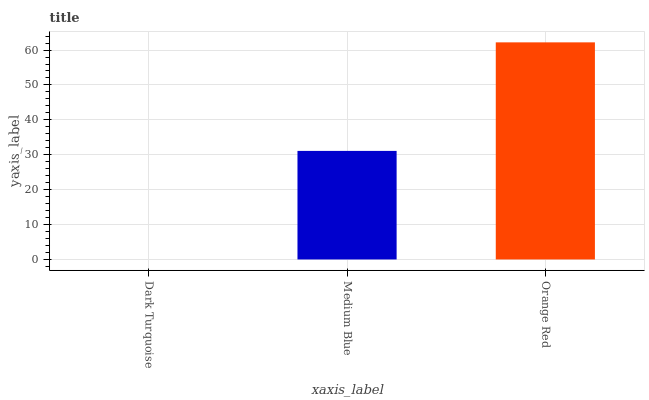Is Dark Turquoise the minimum?
Answer yes or no. Yes. Is Orange Red the maximum?
Answer yes or no. Yes. Is Medium Blue the minimum?
Answer yes or no. No. Is Medium Blue the maximum?
Answer yes or no. No. Is Medium Blue greater than Dark Turquoise?
Answer yes or no. Yes. Is Dark Turquoise less than Medium Blue?
Answer yes or no. Yes. Is Dark Turquoise greater than Medium Blue?
Answer yes or no. No. Is Medium Blue less than Dark Turquoise?
Answer yes or no. No. Is Medium Blue the high median?
Answer yes or no. Yes. Is Medium Blue the low median?
Answer yes or no. Yes. Is Dark Turquoise the high median?
Answer yes or no. No. Is Orange Red the low median?
Answer yes or no. No. 